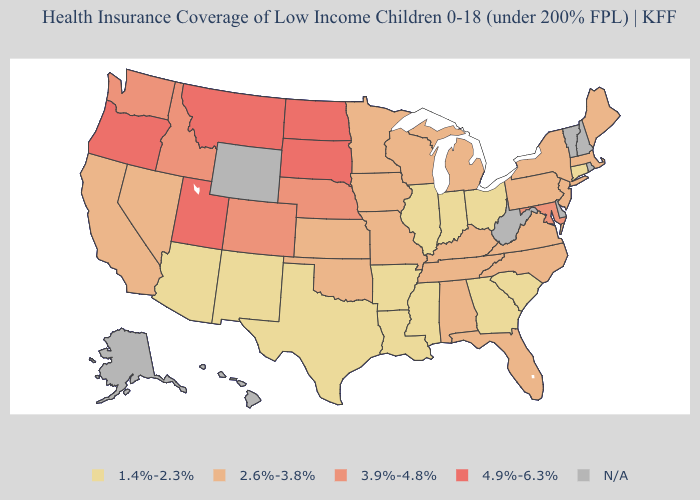Among the states that border Kentucky , which have the lowest value?
Give a very brief answer. Illinois, Indiana, Ohio. Name the states that have a value in the range 3.9%-4.8%?
Answer briefly. Colorado, Idaho, Maryland, Nebraska, Washington. Among the states that border Delaware , which have the lowest value?
Give a very brief answer. New Jersey, Pennsylvania. Which states hav the highest value in the MidWest?
Quick response, please. North Dakota, South Dakota. Does California have the highest value in the West?
Give a very brief answer. No. Which states have the lowest value in the Northeast?
Keep it brief. Connecticut. Name the states that have a value in the range 3.9%-4.8%?
Short answer required. Colorado, Idaho, Maryland, Nebraska, Washington. What is the highest value in the MidWest ?
Be succinct. 4.9%-6.3%. Name the states that have a value in the range 1.4%-2.3%?
Give a very brief answer. Arizona, Arkansas, Connecticut, Georgia, Illinois, Indiana, Louisiana, Mississippi, New Mexico, Ohio, South Carolina, Texas. What is the highest value in the West ?
Be succinct. 4.9%-6.3%. What is the value of Idaho?
Keep it brief. 3.9%-4.8%. Name the states that have a value in the range 4.9%-6.3%?
Keep it brief. Montana, North Dakota, Oregon, South Dakota, Utah. What is the value of Oregon?
Keep it brief. 4.9%-6.3%. Does the first symbol in the legend represent the smallest category?
Give a very brief answer. Yes. What is the value of Montana?
Give a very brief answer. 4.9%-6.3%. 